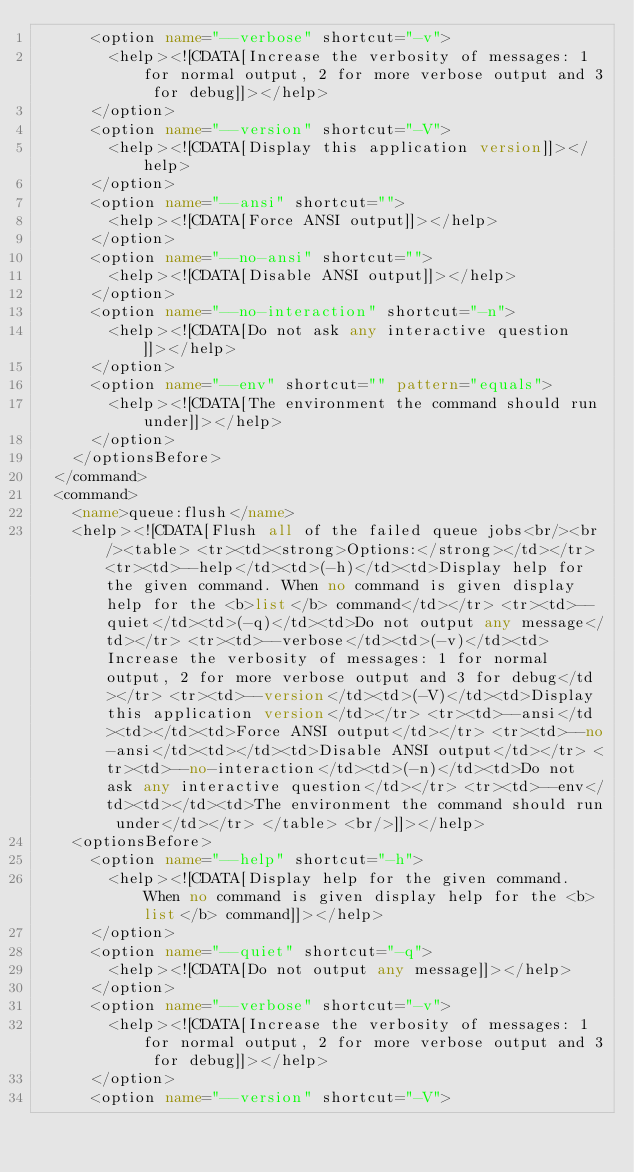<code> <loc_0><loc_0><loc_500><loc_500><_XML_>      <option name="--verbose" shortcut="-v">
        <help><![CDATA[Increase the verbosity of messages: 1 for normal output, 2 for more verbose output and 3 for debug]]></help>
      </option>
      <option name="--version" shortcut="-V">
        <help><![CDATA[Display this application version]]></help>
      </option>
      <option name="--ansi" shortcut="">
        <help><![CDATA[Force ANSI output]]></help>
      </option>
      <option name="--no-ansi" shortcut="">
        <help><![CDATA[Disable ANSI output]]></help>
      </option>
      <option name="--no-interaction" shortcut="-n">
        <help><![CDATA[Do not ask any interactive question]]></help>
      </option>
      <option name="--env" shortcut="" pattern="equals">
        <help><![CDATA[The environment the command should run under]]></help>
      </option>
    </optionsBefore>
  </command>
  <command>
    <name>queue:flush</name>
    <help><![CDATA[Flush all of the failed queue jobs<br/><br/><table> <tr><td><strong>Options:</strong></td></tr> <tr><td>--help</td><td>(-h)</td><td>Display help for the given command. When no command is given display help for the <b>list</b> command</td></tr> <tr><td>--quiet</td><td>(-q)</td><td>Do not output any message</td></tr> <tr><td>--verbose</td><td>(-v)</td><td>Increase the verbosity of messages: 1 for normal output, 2 for more verbose output and 3 for debug</td></tr> <tr><td>--version</td><td>(-V)</td><td>Display this application version</td></tr> <tr><td>--ansi</td><td></td><td>Force ANSI output</td></tr> <tr><td>--no-ansi</td><td></td><td>Disable ANSI output</td></tr> <tr><td>--no-interaction</td><td>(-n)</td><td>Do not ask any interactive question</td></tr> <tr><td>--env</td><td></td><td>The environment the command should run under</td></tr> </table> <br/>]]></help>
    <optionsBefore>
      <option name="--help" shortcut="-h">
        <help><![CDATA[Display help for the given command. When no command is given display help for the <b>list</b> command]]></help>
      </option>
      <option name="--quiet" shortcut="-q">
        <help><![CDATA[Do not output any message]]></help>
      </option>
      <option name="--verbose" shortcut="-v">
        <help><![CDATA[Increase the verbosity of messages: 1 for normal output, 2 for more verbose output and 3 for debug]]></help>
      </option>
      <option name="--version" shortcut="-V"></code> 